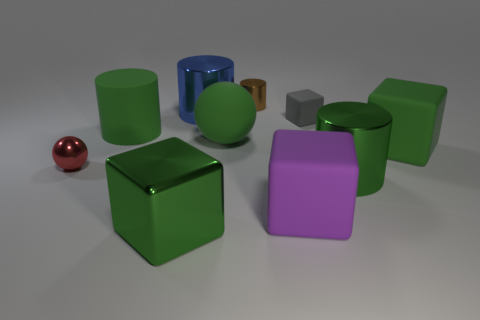Are the large cylinder that is on the right side of the big blue thing and the big green sphere made of the same material?
Offer a terse response. No. What material is the large green block that is left of the big blue shiny object?
Give a very brief answer. Metal. There is a cylinder that is behind the big shiny cylinder that is behind the small red object; what size is it?
Provide a succinct answer. Small. Is there a purple thing made of the same material as the gray object?
Ensure brevity in your answer.  Yes. There is a green metallic thing left of the green cylinder that is right of the large rubber object to the left of the green metal block; what is its shape?
Your response must be concise. Cube. There is a large metallic cylinder that is right of the large blue metallic object; is its color the same as the big block on the left side of the small metal cylinder?
Offer a very short reply. Yes. There is a small cube; are there any tiny gray matte things behind it?
Keep it short and to the point. No. How many green things are the same shape as the gray rubber object?
Give a very brief answer. 2. There is a large cube that is behind the tiny thing that is in front of the green matte object on the right side of the tiny cube; what is its color?
Your answer should be very brief. Green. Do the big green cylinder that is left of the big matte sphere and the large cube behind the red ball have the same material?
Offer a very short reply. Yes. 